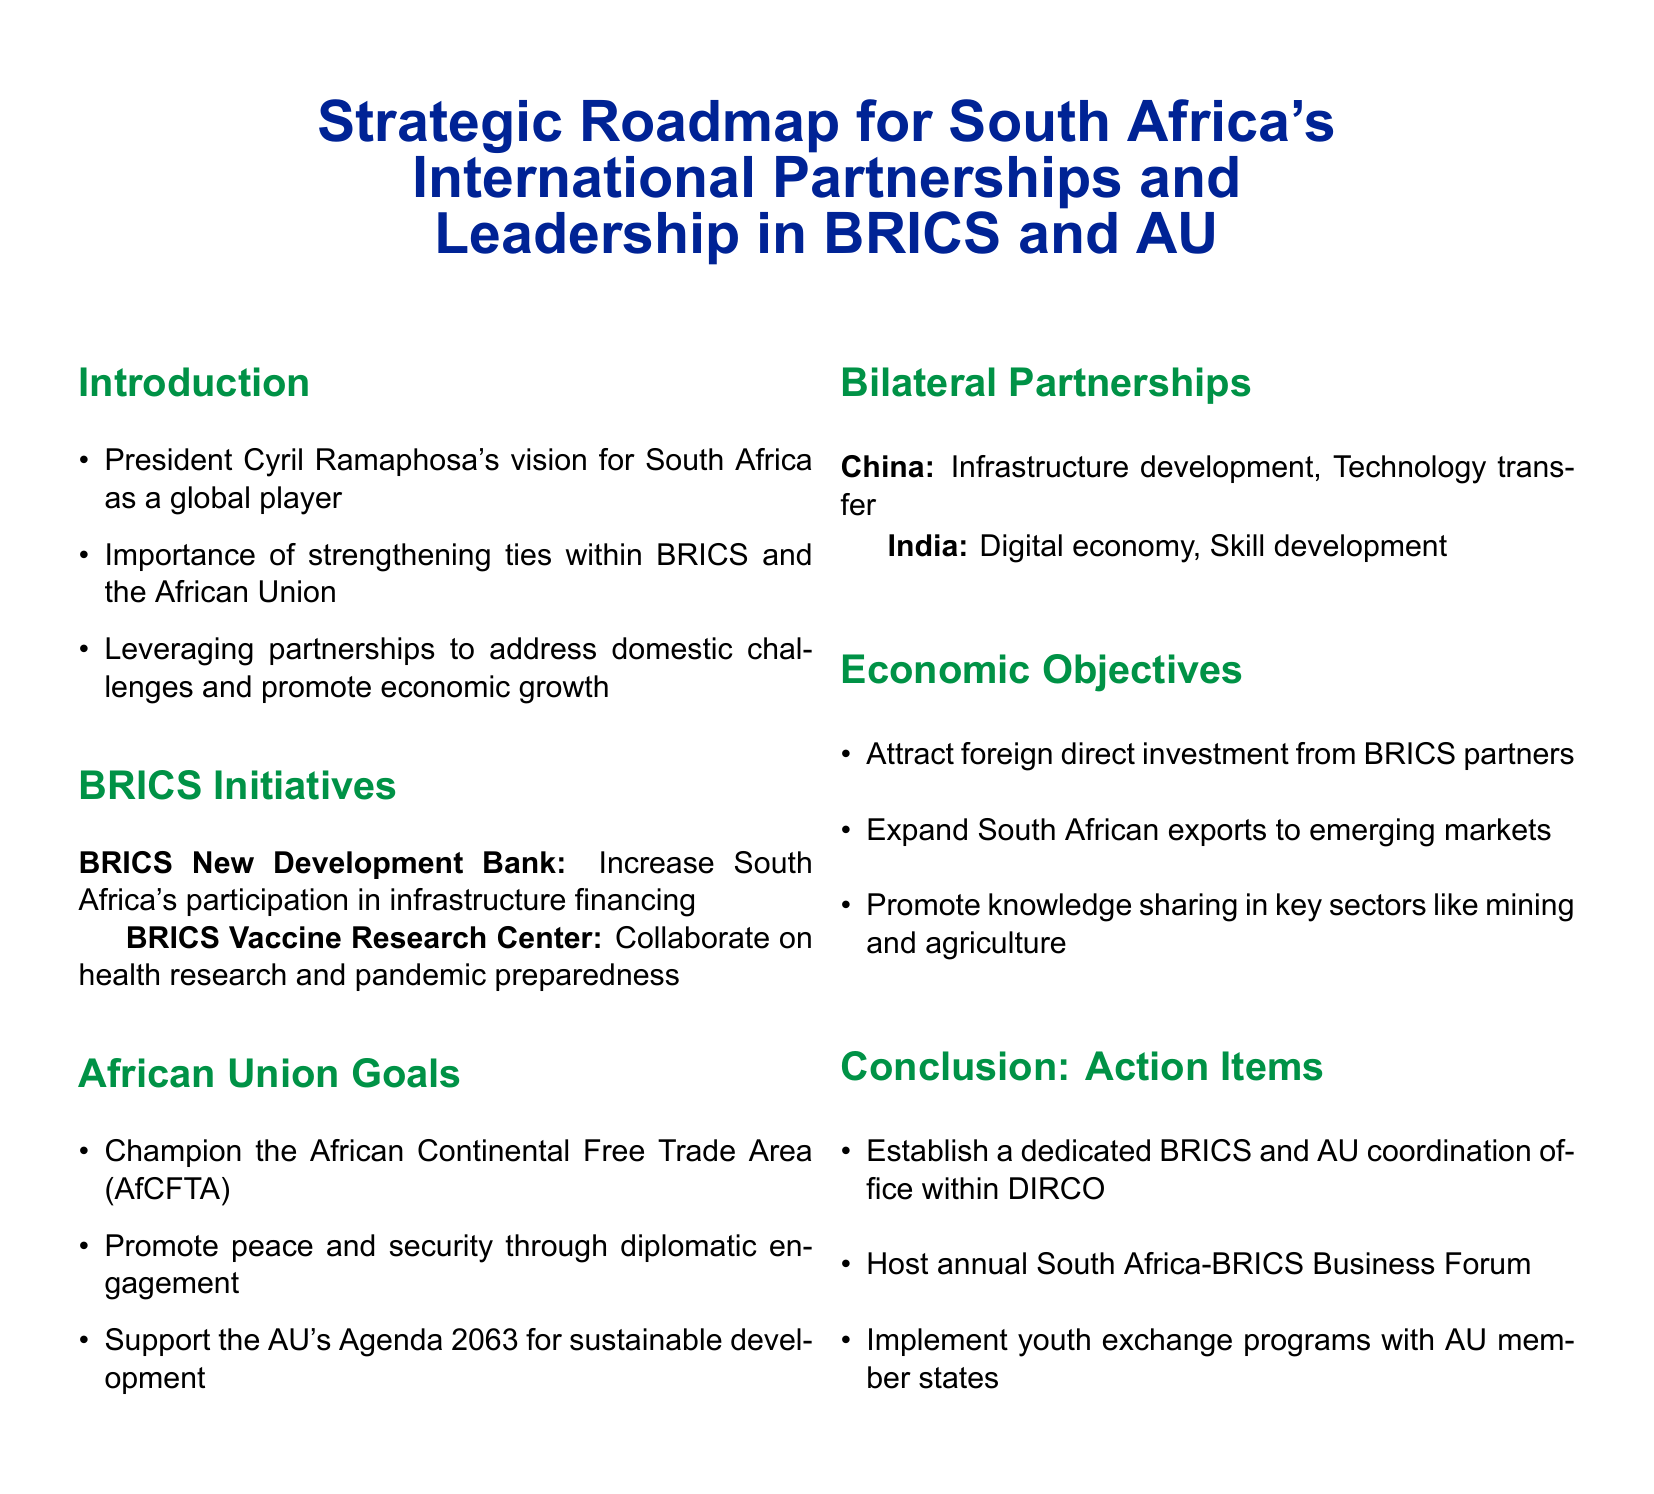What is the title of the document? The title is presented prominently at the beginning of the document, summarizing its focus.
Answer: Strategic Roadmap for South Africa's International Partnerships and Leadership in BRICS and AU Who is the President associated with the vision in the document? The document attributes a vision for South Africa's global role to the current president.
Answer: Cyril Ramaphosa What is one of the goals of the African Union mentioned? The document lists goals related to the African Union to highlight South Africa's involvement in regional initiatives.
Answer: Champion the African Continental Free Trade Area (AfCFTA) Which country is mentioned in relation to technology transfer? The document outlines specific bilateral partnerships and highlights collaborations with certain countries.
Answer: China What is one of the action items proposed in the conclusion? The conclusion summarizes actionable steps that South Africa can take to enhance its international partnerships.
Answer: Establish a dedicated BRICS and AU coordination office within DIRCO What is the focus of the BRICS Vaccine Research Center? The document outlines specific initiatives related to BRICS to emphasize cooperative efforts in health.
Answer: Collaborate on health research and pandemic preparedness What is emphasized as an objective for attracting investment? The document clearly states the goals related to foreign direct investment from specific partners.
Answer: Attract foreign direct investment from BRICS partners What is one sector mentioned for knowledge sharing? The document specifies key sectors where South Africa can exchange knowledge with its partners.
Answer: Mining 